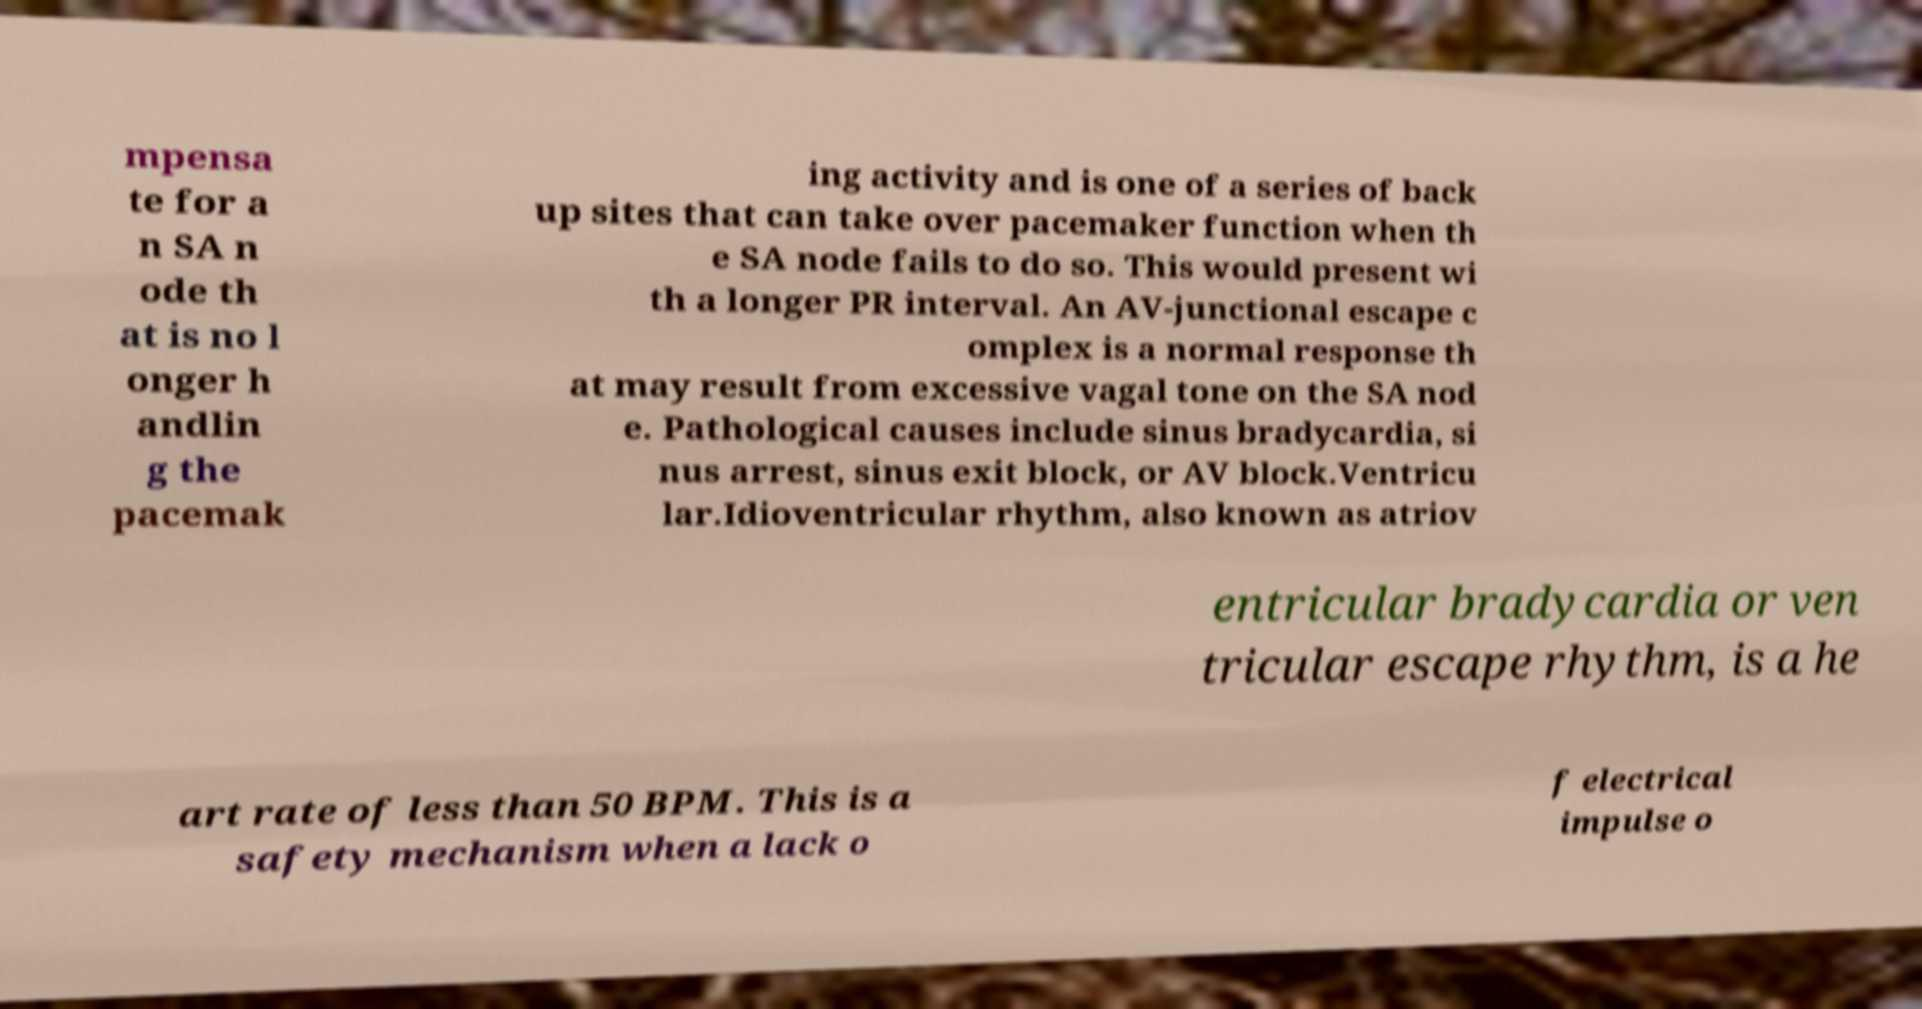What messages or text are displayed in this image? I need them in a readable, typed format. mpensa te for a n SA n ode th at is no l onger h andlin g the pacemak ing activity and is one of a series of back up sites that can take over pacemaker function when th e SA node fails to do so. This would present wi th a longer PR interval. An AV-junctional escape c omplex is a normal response th at may result from excessive vagal tone on the SA nod e. Pathological causes include sinus bradycardia, si nus arrest, sinus exit block, or AV block.Ventricu lar.Idioventricular rhythm, also known as atriov entricular bradycardia or ven tricular escape rhythm, is a he art rate of less than 50 BPM. This is a safety mechanism when a lack o f electrical impulse o 